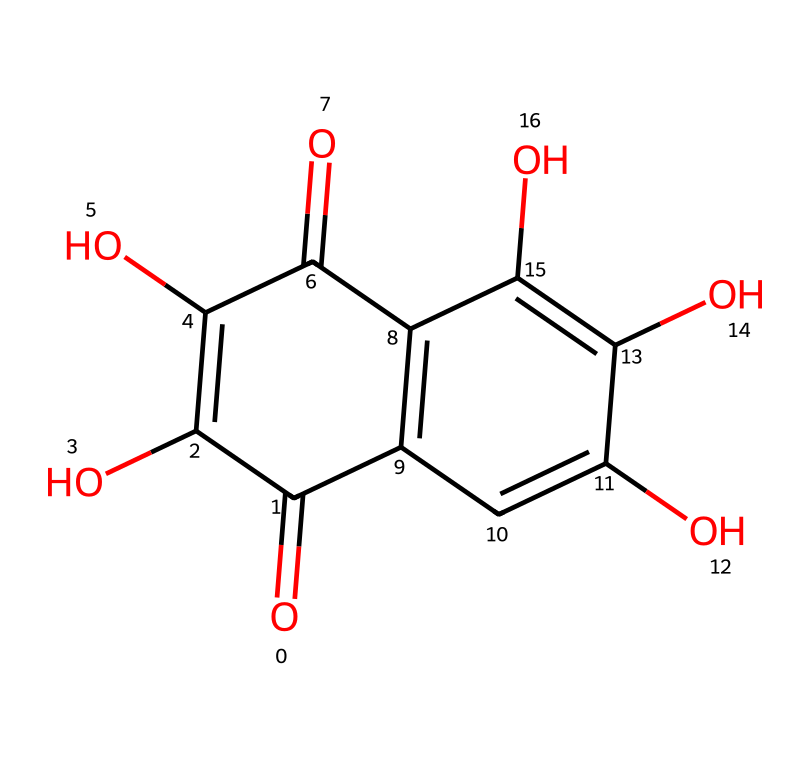What is the molecular formula of quercetin? The SMILES representation includes multiple atoms of carbon (C), hydrogen (H), and oxygen (O). By counting the elements in the structure, it can be deduced that there are 15 carbons, 10 hydrogens, and 7 oxygens, giving the molecular formula C15H10O7.
Answer: C15H10O7 How many aromatic rings does quercetin contain? Analyzing the chemical structure, it features two distinct sets of conjugated double bonds that characterize aromatic structures. Hence, quercetin contains two aromatic rings.
Answer: two What color is typically associated with flavonoid compounds like quercetin? Flavonoids are known for their vibrant colors, often ranging from yellow to red. Quercetin, specifically, is recognized for its yellow pigmentation.
Answer: yellow How many hydroxyl groups are present in the quercetin structure? By scrutinizing the structure, hydroxyl groups (–OH) can be identified. Quercetin contains a total of five –OH groups attached to its carbon skeleton.
Answer: five What is the primary role of quercetin in plants? Quercetin serves primarily as an antioxidant, protecting plants from oxidative stress and UV radiation, which helps in their survival and growth.
Answer: antioxidant What does the presence of multiple hydroxy groups suggest about the solubility of quercetin? The multiple hydroxyl groups in the quercetin structure enhance its ability to interact with polar solvents, indicating that quercetin is soluble in water due to its hydrophilic nature.
Answer: soluble in water How does quercetin contribute to human health? Quercetin is well-regarded for its antioxidant properties, potentially reducing inflammation and combating oxidative stress, which can benefit overall human health.
Answer: reduces inflammation 